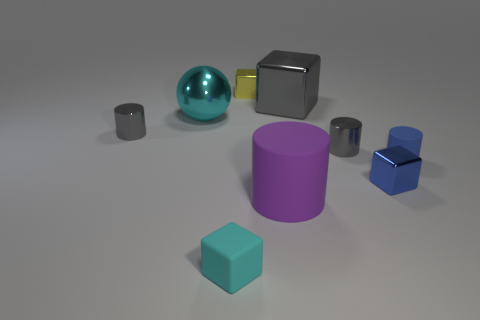Is there a tiny red shiny sphere?
Provide a succinct answer. No. The cube that is both behind the blue cube and on the left side of the large cylinder is made of what material?
Provide a succinct answer. Metal. Are there more tiny blue matte cylinders to the left of the purple thing than small blue blocks that are behind the tiny blue rubber cylinder?
Offer a terse response. No. Are there any blue rubber things that have the same size as the cyan matte thing?
Keep it short and to the point. Yes. What size is the gray block that is right of the cyan thing in front of the small metallic cylinder left of the cyan cube?
Offer a very short reply. Large. The tiny rubber cube is what color?
Ensure brevity in your answer.  Cyan. Are there more blue cylinders that are on the left side of the rubber cube than small blue rubber objects?
Keep it short and to the point. No. What number of tiny gray shiny cylinders are in front of the small yellow metallic cube?
Make the answer very short. 2. What shape is the matte object that is the same color as the big metal ball?
Make the answer very short. Cube. Is there a matte object right of the large shiny sphere on the left side of the tiny gray object that is right of the big cyan object?
Offer a terse response. Yes. 